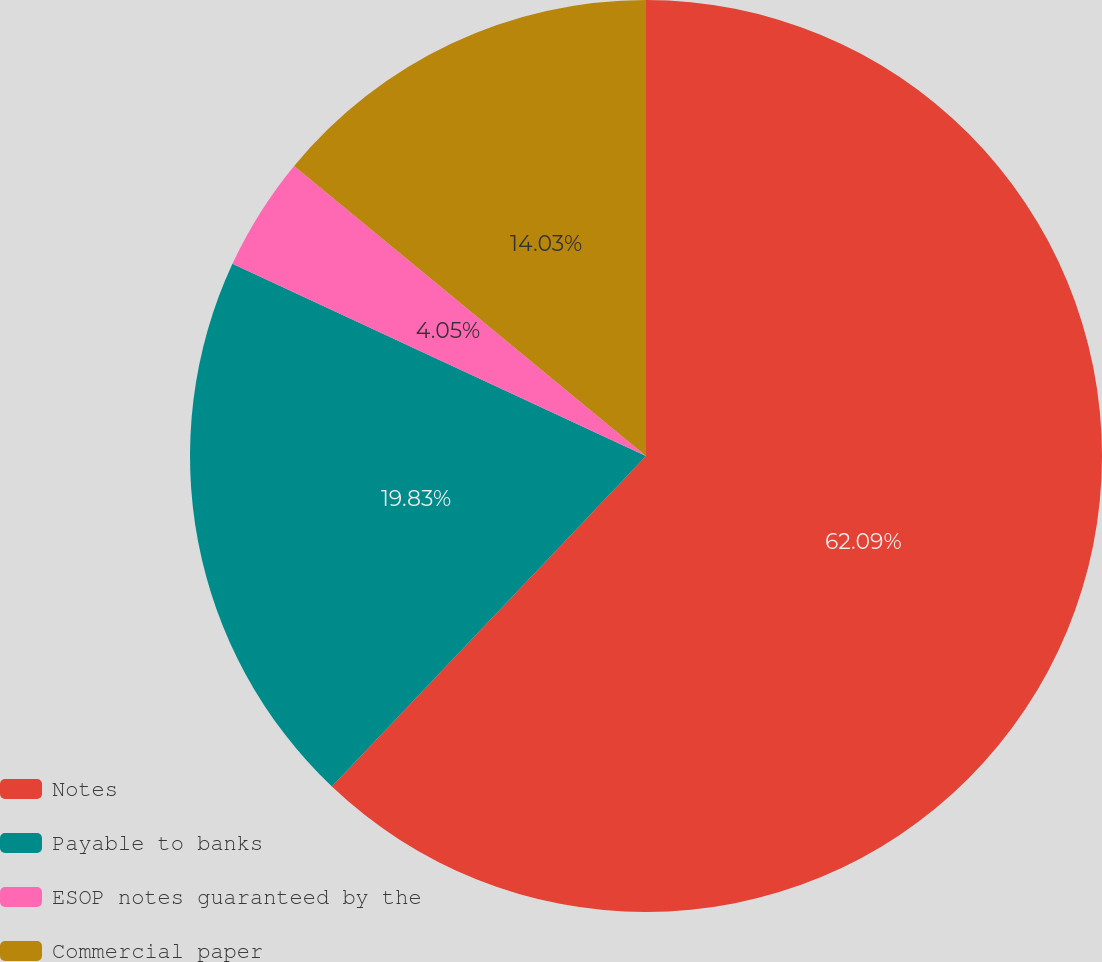Convert chart. <chart><loc_0><loc_0><loc_500><loc_500><pie_chart><fcel>Notes<fcel>Payable to banks<fcel>ESOP notes guaranteed by the<fcel>Commercial paper<nl><fcel>62.1%<fcel>19.83%<fcel>4.05%<fcel>14.03%<nl></chart> 